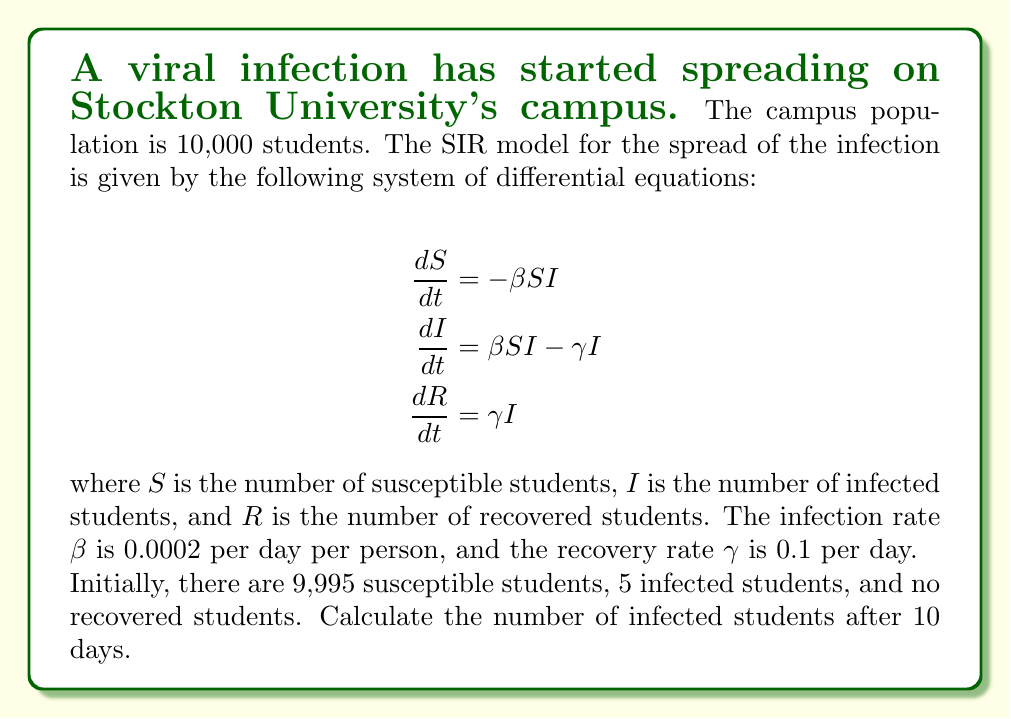What is the answer to this math problem? To solve this problem, we need to use numerical methods to approximate the solution of the SIR model. We'll use the Euler method with a step size of 1 day.

Let's define our initial conditions:
$S_0 = 9995$, $I_0 = 5$, $R_0 = 0$
$\beta = 0.0002$, $\gamma = 0.1$

The Euler method for our system of equations is:

$$\begin{align}
S_{n+1} &= S_n - \beta S_n I_n \Delta t \\
I_{n+1} &= I_n + (\beta S_n I_n - \gamma I_n) \Delta t \\
R_{n+1} &= R_n + \gamma I_n \Delta t
\end{align}$$

where $\Delta t = 1$ day.

Let's calculate for 10 days:

Day 0: $S_0 = 9995$, $I_0 = 5$, $R_0 = 0$

Day 1:
$S_1 = 9995 - 0.0002 \cdot 9995 \cdot 5 \cdot 1 = 9995 - 9.995 = 9985.005$
$I_1 = 5 + (0.0002 \cdot 9995 \cdot 5 - 0.1 \cdot 5) \cdot 1 = 5 + 9.995 - 0.5 = 14.495$
$R_1 = 0 + 0.1 \cdot 5 \cdot 1 = 0.5$

Day 2:
$S_2 = 9985.005 - 0.0002 \cdot 9985.005 \cdot 14.495 \cdot 1 = 9956.042$
$I_2 = 14.495 + (0.0002 \cdot 9985.005 \cdot 14.495 - 0.1 \cdot 14.495) \cdot 1 = 41.963$
$R_2 = 0.5 + 0.1 \cdot 14.495 \cdot 1 = 1.95$

We continue this process for the remaining days. After 10 iterations, we get:

Day 10:
$S_{10} = 9214.378$
$I_{10} = 725.622$
$R_{10} = 60.000$
Answer: After 10 days, the number of infected students is approximately 726 (rounded to the nearest whole number). 